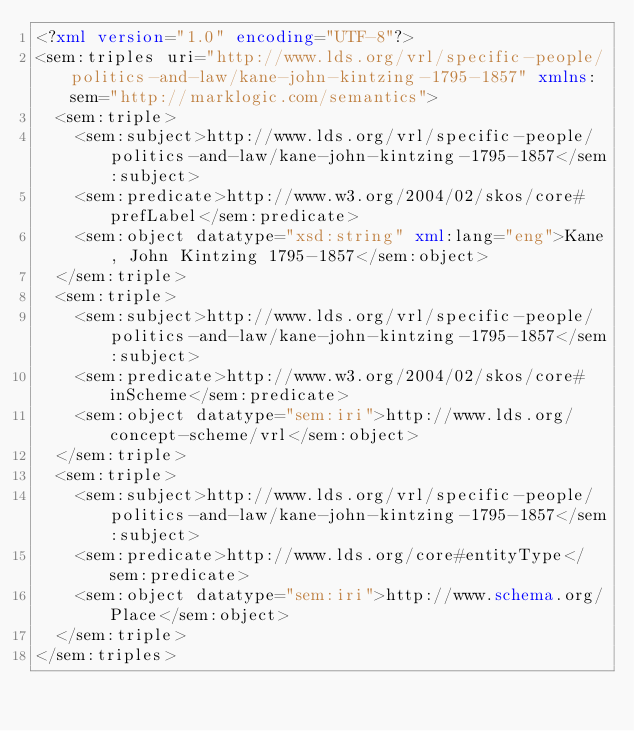<code> <loc_0><loc_0><loc_500><loc_500><_XML_><?xml version="1.0" encoding="UTF-8"?>
<sem:triples uri="http://www.lds.org/vrl/specific-people/politics-and-law/kane-john-kintzing-1795-1857" xmlns:sem="http://marklogic.com/semantics">
  <sem:triple>
    <sem:subject>http://www.lds.org/vrl/specific-people/politics-and-law/kane-john-kintzing-1795-1857</sem:subject>
    <sem:predicate>http://www.w3.org/2004/02/skos/core#prefLabel</sem:predicate>
    <sem:object datatype="xsd:string" xml:lang="eng">Kane, John Kintzing 1795-1857</sem:object>
  </sem:triple>
  <sem:triple>
    <sem:subject>http://www.lds.org/vrl/specific-people/politics-and-law/kane-john-kintzing-1795-1857</sem:subject>
    <sem:predicate>http://www.w3.org/2004/02/skos/core#inScheme</sem:predicate>
    <sem:object datatype="sem:iri">http://www.lds.org/concept-scheme/vrl</sem:object>
  </sem:triple>
  <sem:triple>
    <sem:subject>http://www.lds.org/vrl/specific-people/politics-and-law/kane-john-kintzing-1795-1857</sem:subject>
    <sem:predicate>http://www.lds.org/core#entityType</sem:predicate>
    <sem:object datatype="sem:iri">http://www.schema.org/Place</sem:object>
  </sem:triple>
</sem:triples>
</code> 